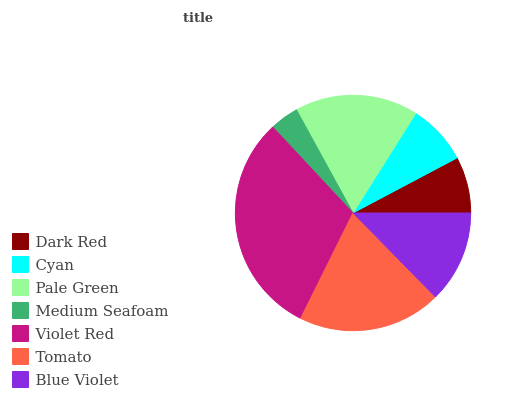Is Medium Seafoam the minimum?
Answer yes or no. Yes. Is Violet Red the maximum?
Answer yes or no. Yes. Is Cyan the minimum?
Answer yes or no. No. Is Cyan the maximum?
Answer yes or no. No. Is Cyan greater than Dark Red?
Answer yes or no. Yes. Is Dark Red less than Cyan?
Answer yes or no. Yes. Is Dark Red greater than Cyan?
Answer yes or no. No. Is Cyan less than Dark Red?
Answer yes or no. No. Is Blue Violet the high median?
Answer yes or no. Yes. Is Blue Violet the low median?
Answer yes or no. Yes. Is Dark Red the high median?
Answer yes or no. No. Is Dark Red the low median?
Answer yes or no. No. 